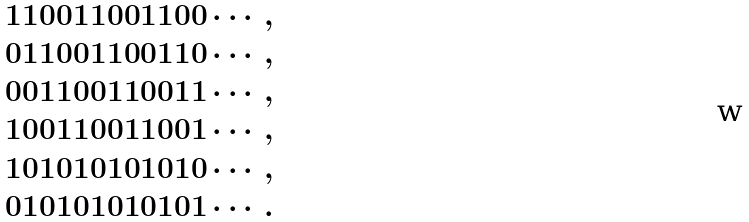Convert formula to latex. <formula><loc_0><loc_0><loc_500><loc_500>& 1 1 0 0 1 1 0 0 1 1 0 0 \cdots , \\ & 0 1 1 0 0 1 1 0 0 1 1 0 \cdots , \\ & 0 0 1 1 0 0 1 1 0 0 1 1 \cdots , \\ & 1 0 0 1 1 0 0 1 1 0 0 1 \cdots , \\ & 1 0 1 0 1 0 1 0 1 0 1 0 \cdots , \\ & 0 1 0 1 0 1 0 1 0 1 0 1 \cdots .</formula> 